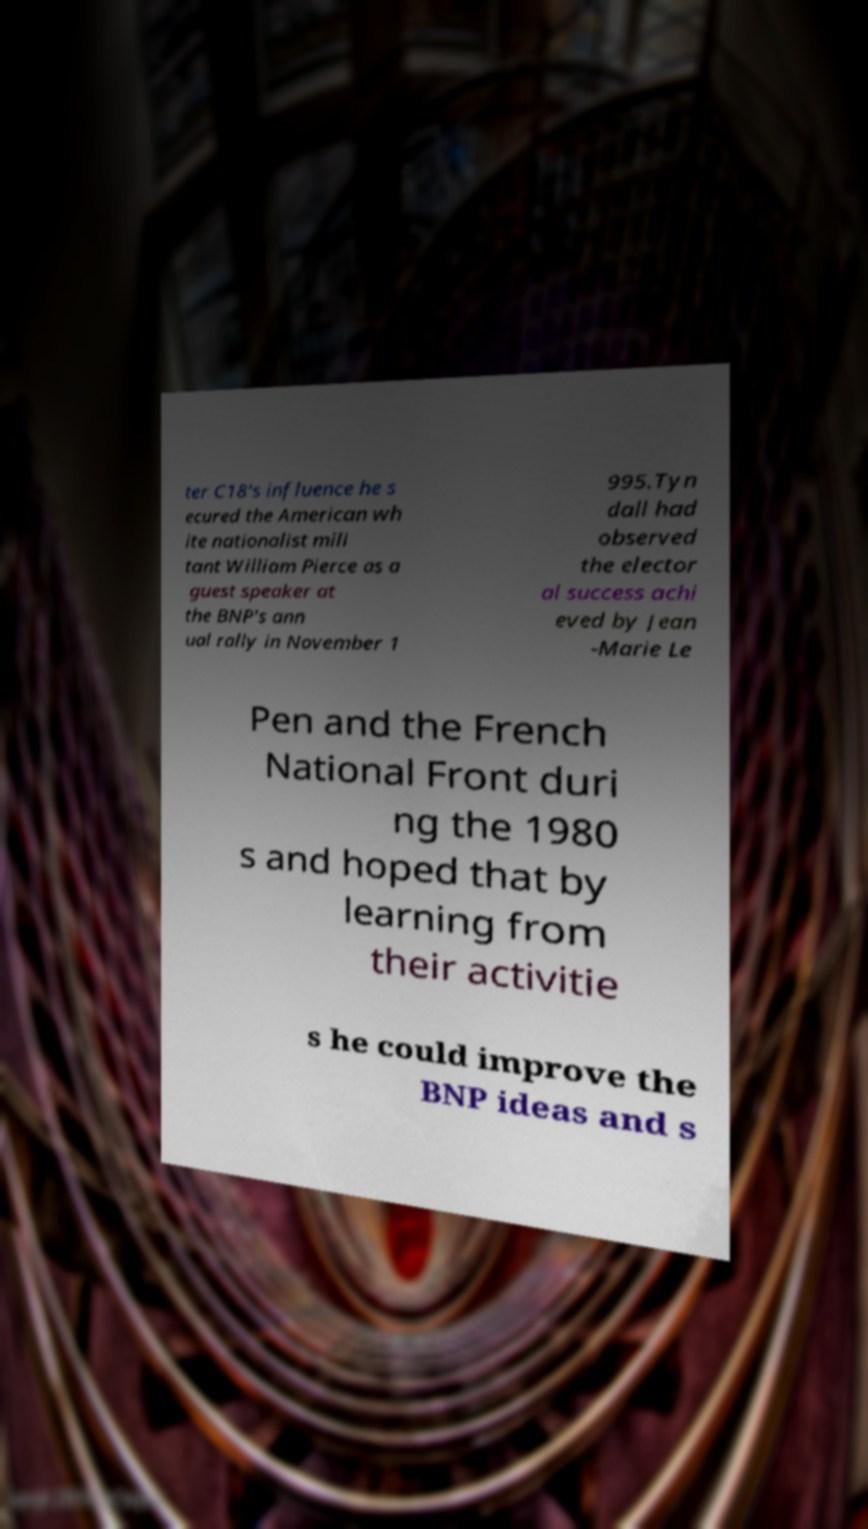There's text embedded in this image that I need extracted. Can you transcribe it verbatim? ter C18's influence he s ecured the American wh ite nationalist mili tant William Pierce as a guest speaker at the BNP's ann ual rally in November 1 995.Tyn dall had observed the elector al success achi eved by Jean -Marie Le Pen and the French National Front duri ng the 1980 s and hoped that by learning from their activitie s he could improve the BNP ideas and s 